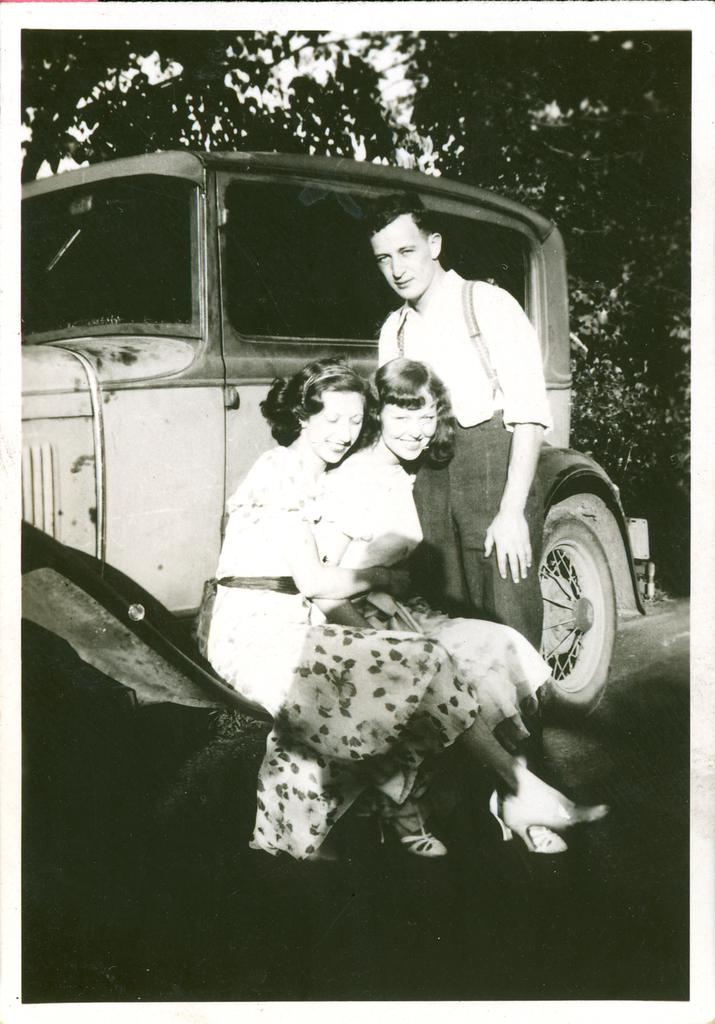How many people are sitting in the image? There are two persons sitting in the image. What is the person near doing in the image? The person standing near a vehicle in the image. What can be seen in the background of the image? There are trees and the sky visible in the background of the image. What type of furniture can be seen in the image? There is no furniture present in the image. What color is the shade on the vehicle in the image? There is no shade visible on the vehicle in the image. 